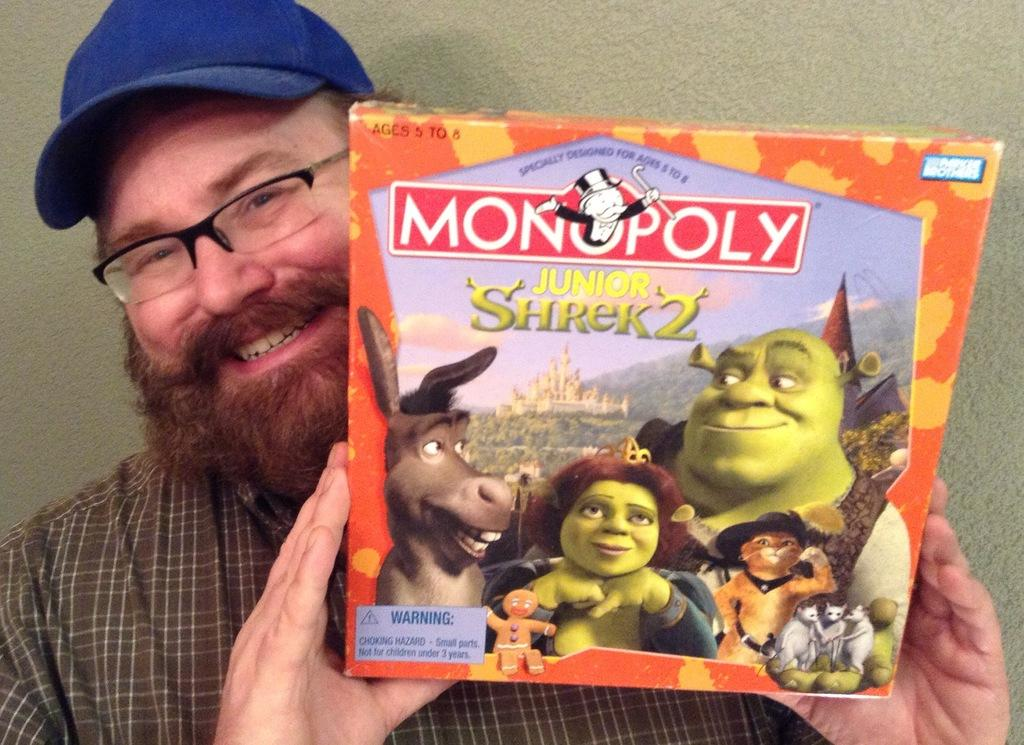What is the man in the image doing? The man is holding a box in the image. What is the man's facial expression in the image? The man is smiling in the image. What can be seen in the background of the image? There is a wall in the background of the image. What type of wool is the man using to create his artwork in the image? There is no wool or artwork present in the image; the man is holding a box and smiling. 